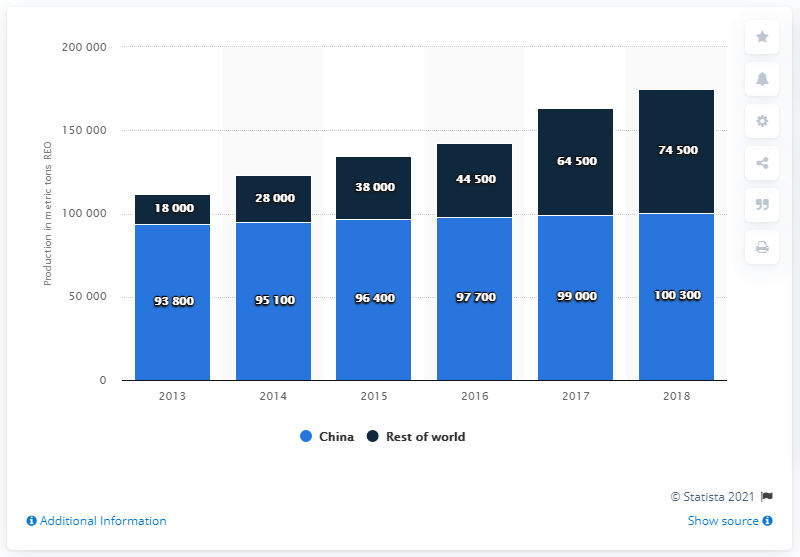Highlight a few significant elements in this photo. In 2018, the estimated production of rare earth worldwide was approximately 74,500 metric tons. 